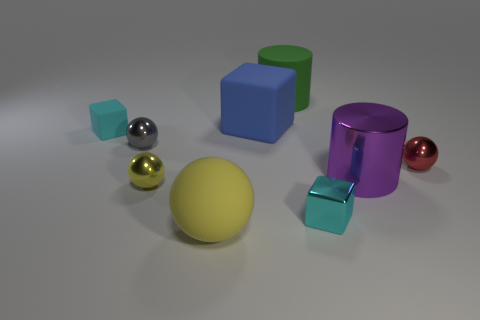Subtract all cyan metallic cubes. How many cubes are left? 2 Subtract all gray spheres. How many spheres are left? 3 Subtract all cylinders. How many objects are left? 7 Subtract 1 balls. How many balls are left? 3 Subtract all cyan cylinders. Subtract all green balls. How many cylinders are left? 2 Subtract all brown blocks. How many gray cylinders are left? 0 Subtract all big yellow cylinders. Subtract all blocks. How many objects are left? 6 Add 6 small gray spheres. How many small gray spheres are left? 7 Add 3 small metallic balls. How many small metallic balls exist? 6 Subtract 0 brown cubes. How many objects are left? 9 